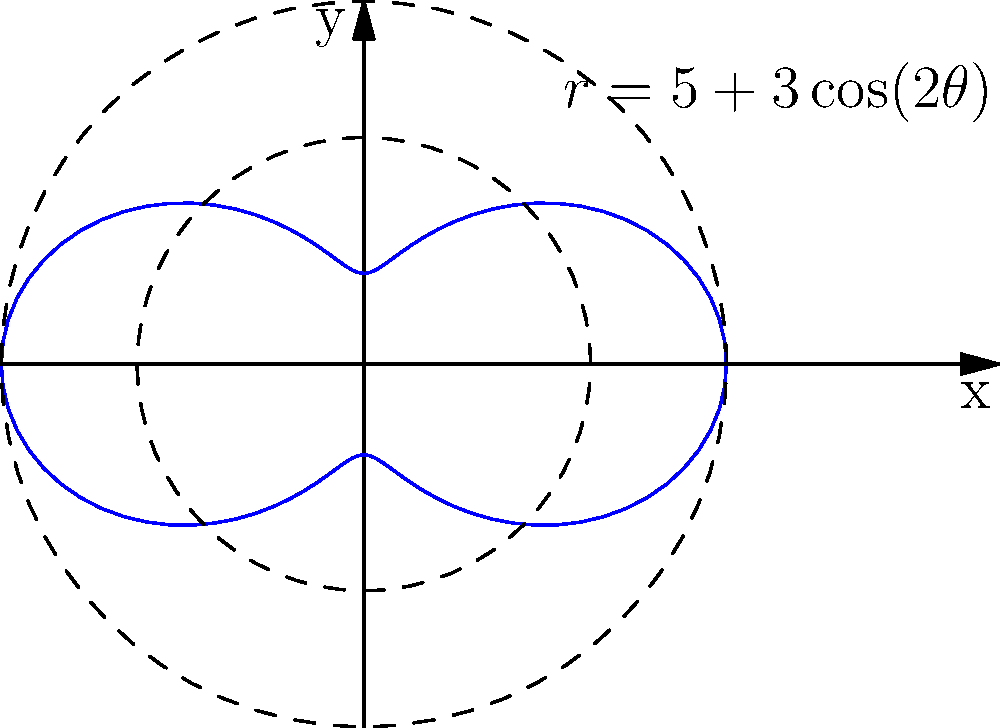As a sales executive, you're analyzing the market coverage of a new product. The coverage area is represented by the polar equation $r = 5 + 3\cos(2\theta)$, where $r$ is in kilometers. Calculate the total area of market coverage in square kilometers. To calculate the area enclosed by a polar curve, we use the formula:

$$ A = \frac{1}{2} \int_{0}^{2\pi} r^2(\theta) d\theta $$

1) Substitute the given equation: $r = 5 + 3\cos(2\theta)$

2) Square the equation:
   $r^2 = (5 + 3\cos(2\theta))^2 = 25 + 30\cos(2\theta) + 9\cos^2(2\theta)$

3) Set up the integral:
   $$ A = \frac{1}{2} \int_{0}^{2\pi} (25 + 30\cos(2\theta) + 9\cos^2(2\theta)) d\theta $$

4) Integrate term by term:
   - $\int_{0}^{2\pi} 25 d\theta = 25\theta |_{0}^{2\pi} = 50\pi$
   - $\int_{0}^{2\pi} 30\cos(2\theta) d\theta = 15\sin(2\theta) |_{0}^{2\pi} = 0$
   - $\int_{0}^{2\pi} 9\cos^2(2\theta) d\theta = \frac{9}{2}\theta + \frac{9}{4}\sin(4\theta) |_{0}^{2\pi} = 9\pi$

5) Sum the results and multiply by $\frac{1}{2}$:
   $$ A = \frac{1}{2} (50\pi + 0 + 9\pi) = \frac{59\pi}{2} $$

Therefore, the total area of market coverage is $\frac{59\pi}{2}$ square kilometers.
Answer: $\frac{59\pi}{2}$ sq km 